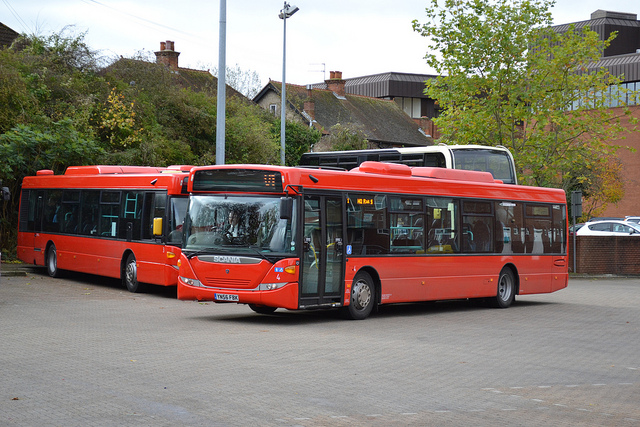Please identify all text content in this image. SCANIA 